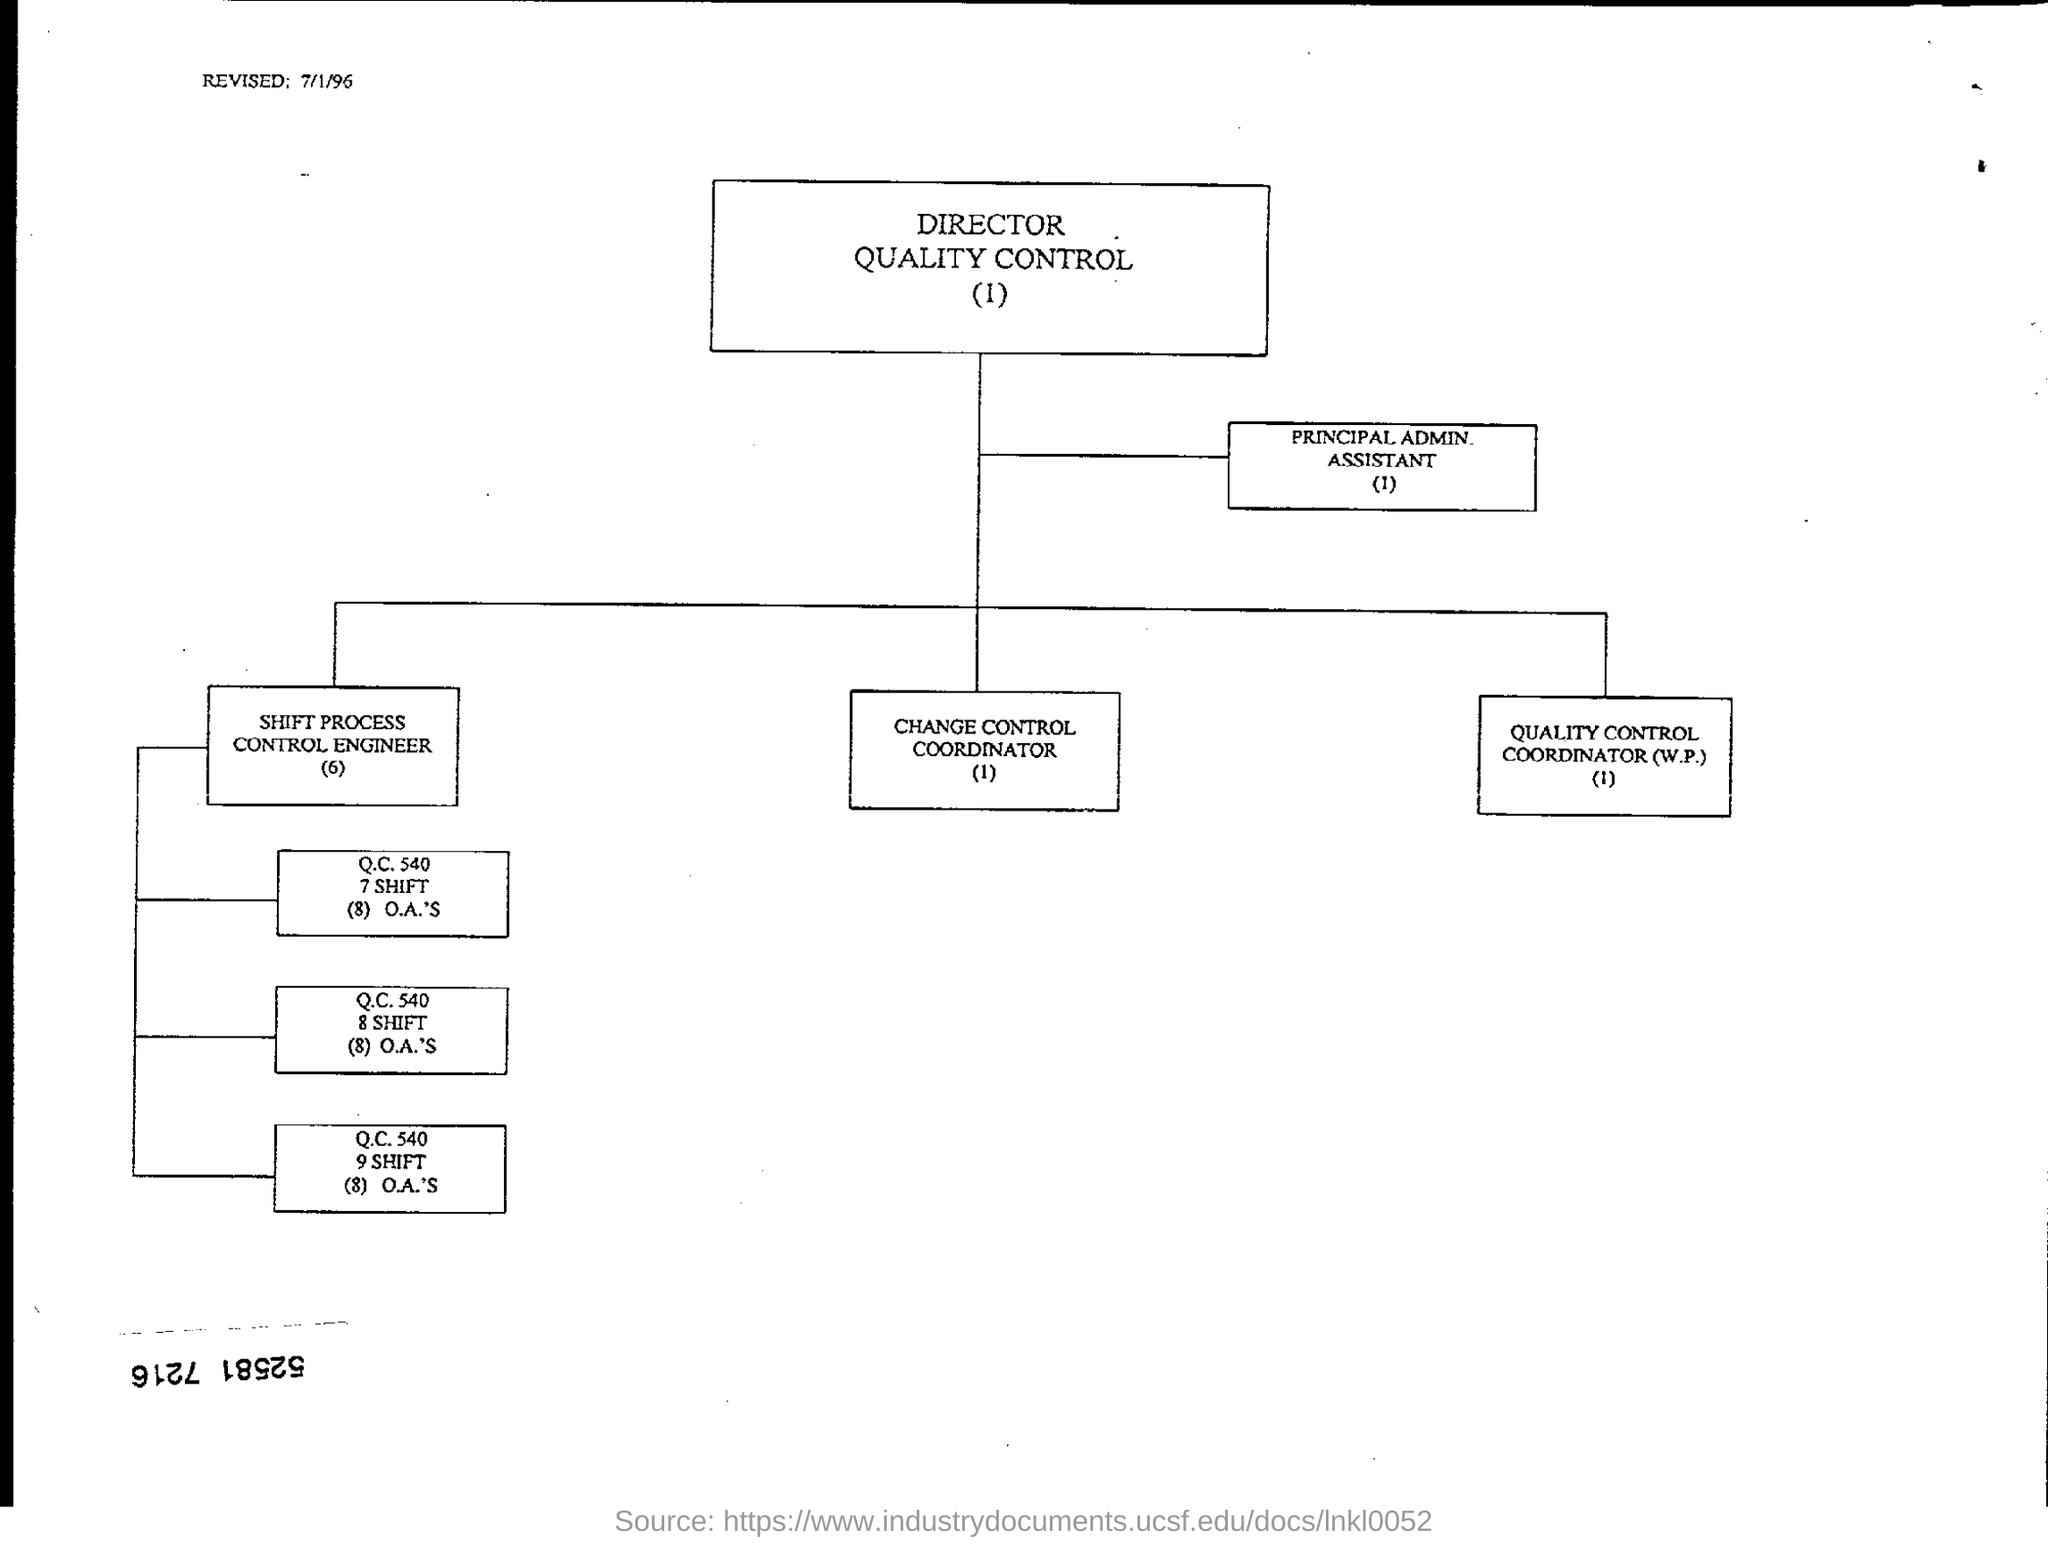Highlight a few significant elements in this photo. The revised date at the top left of the page is 7/1/96. 